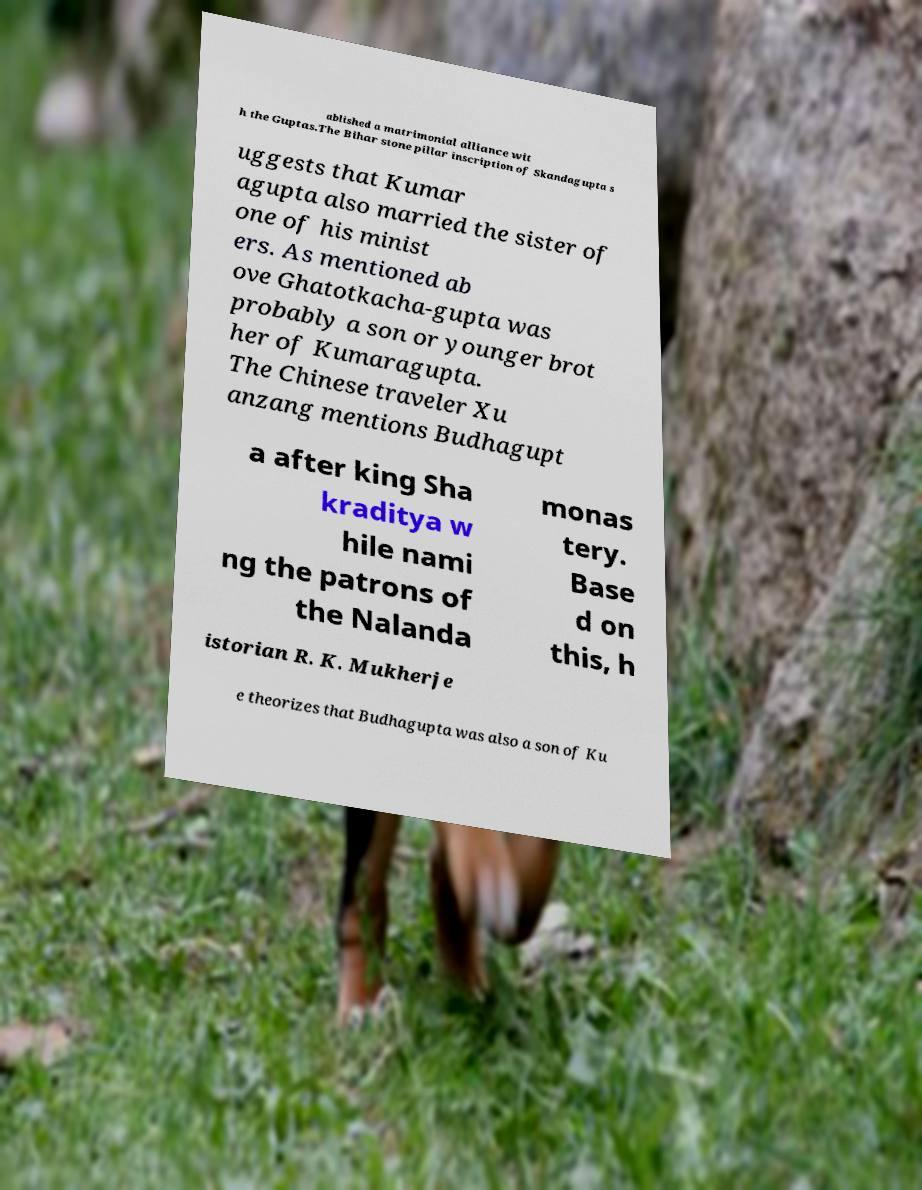What messages or text are displayed in this image? I need them in a readable, typed format. ablished a matrimonial alliance wit h the Guptas.The Bihar stone pillar inscription of Skandagupta s uggests that Kumar agupta also married the sister of one of his minist ers. As mentioned ab ove Ghatotkacha-gupta was probably a son or younger brot her of Kumaragupta. The Chinese traveler Xu anzang mentions Budhagupt a after king Sha kraditya w hile nami ng the patrons of the Nalanda monas tery. Base d on this, h istorian R. K. Mukherje e theorizes that Budhagupta was also a son of Ku 